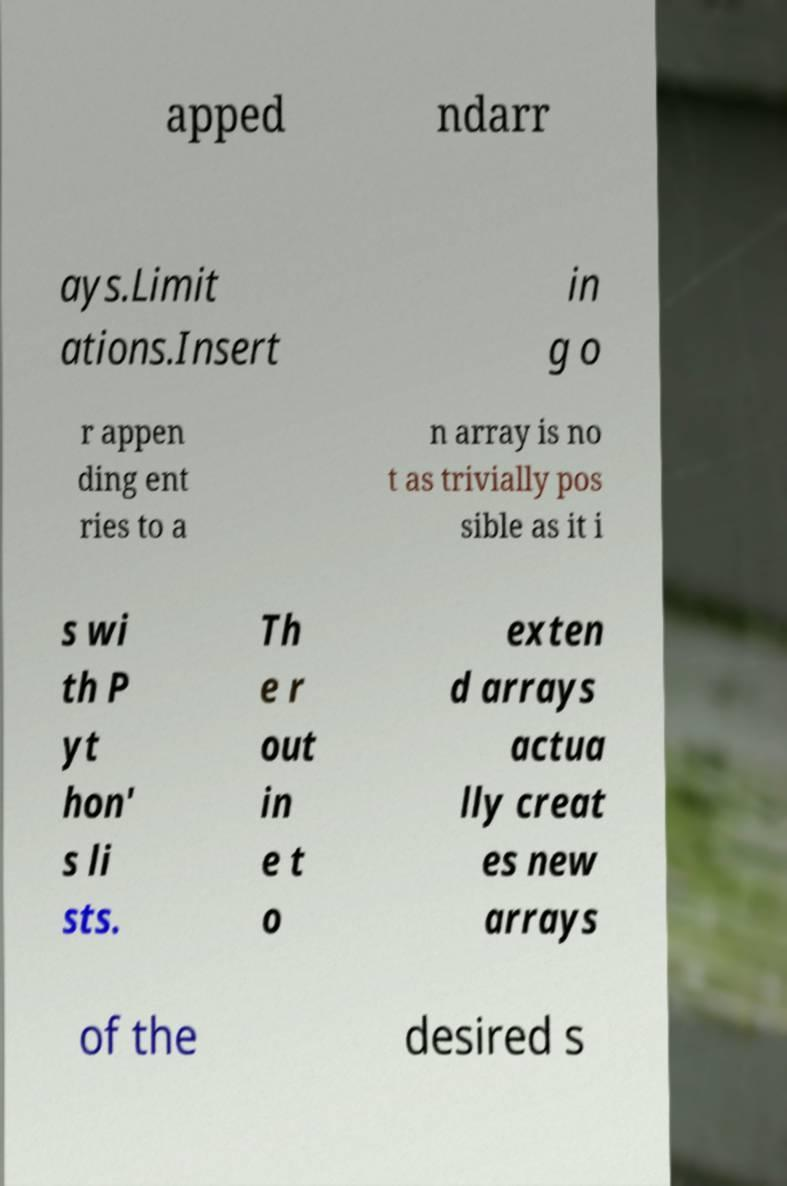For documentation purposes, I need the text within this image transcribed. Could you provide that? apped ndarr ays.Limit ations.Insert in g o r appen ding ent ries to a n array is no t as trivially pos sible as it i s wi th P yt hon' s li sts. Th e r out in e t o exten d arrays actua lly creat es new arrays of the desired s 